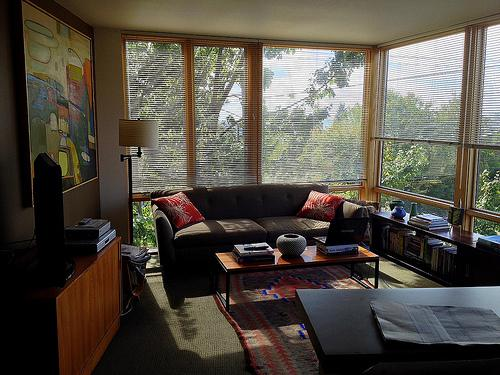Question: when was this picture taken?
Choices:
A. Before lunch.
B. At dusk.
C. During the daylight.
D. Just before supper.
Answer with the letter. Answer: C Question: where was this picture taken?
Choices:
A. In a living room.
B. In  the kitchen.
C. At a park.
D. At a mall.
Answer with the letter. Answer: A Question: what was the weather like in this photo?
Choices:
A. Foggy.
B. Sunny.
C. Rainy.
D. Snowy m.
Answer with the letter. Answer: A Question: what does the photo capture?
Choices:
A. The skyline.
B. The family.
C. The backyard.
D. The picture of a room.
Answer with the letter. Answer: D 